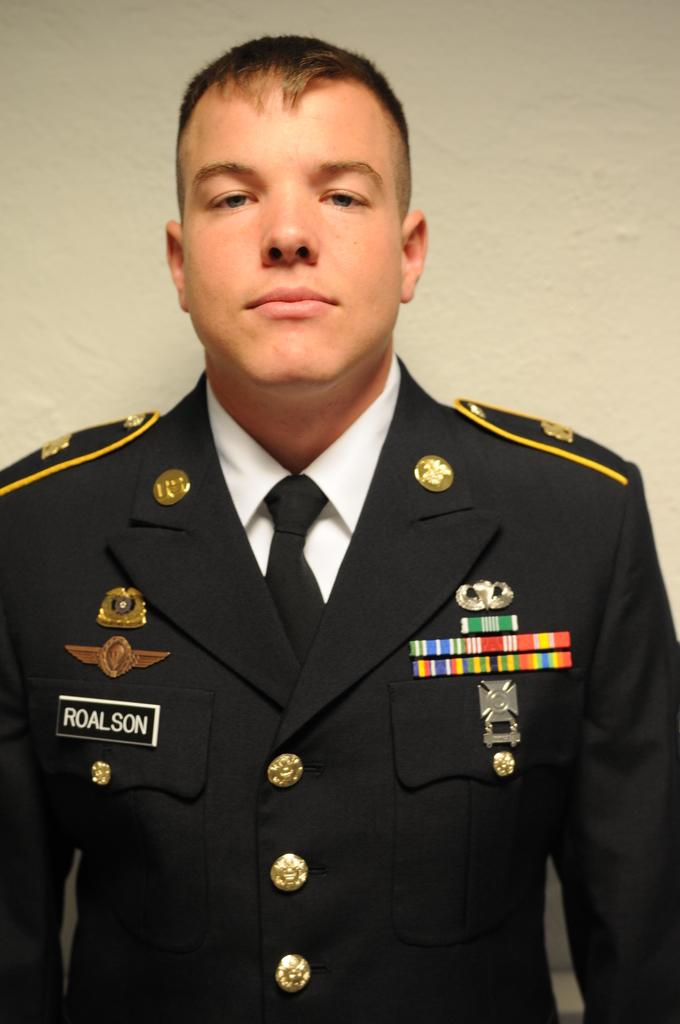What is the main subject of the image? There is a person standing in the image. What is the person wearing? The person is wearing a black and white uniform and a black tie. What color is the background wall in the image? The background wall is white. What type of monkey can be seen climbing the white wall in the image? There is no monkey present in the image; it features a person standing in a black and white uniform with a black tie in front of a white wall. 